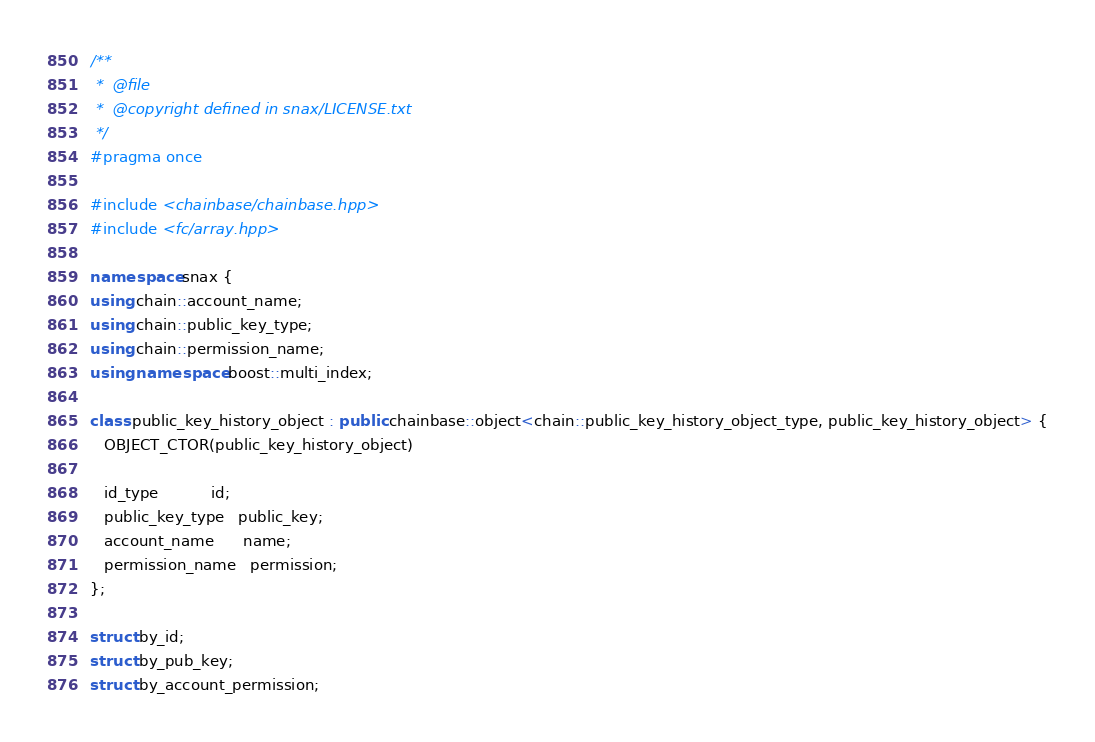<code> <loc_0><loc_0><loc_500><loc_500><_C++_>/**
 *  @file
 *  @copyright defined in snax/LICENSE.txt
 */
#pragma once

#include <chainbase/chainbase.hpp>
#include <fc/array.hpp>

namespace snax {
using chain::account_name;
using chain::public_key_type;
using chain::permission_name;
using namespace boost::multi_index;

class public_key_history_object : public chainbase::object<chain::public_key_history_object_type, public_key_history_object> {
   OBJECT_CTOR(public_key_history_object)

   id_type           id;
   public_key_type   public_key;
   account_name      name;
   permission_name   permission;
};

struct by_id;
struct by_pub_key;
struct by_account_permission;</code> 